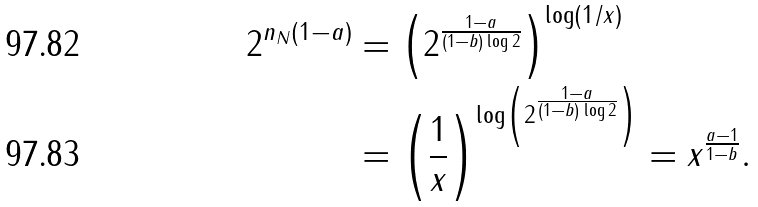<formula> <loc_0><loc_0><loc_500><loc_500>2 ^ { n _ { N } ( 1 - a ) } & = \left ( 2 ^ { \frac { 1 - a } { ( 1 - b ) \log 2 } } \right ) ^ { \log ( 1 / x ) } \\ & = \left ( \frac { 1 } { x } \right ) ^ { \log \left ( 2 ^ { \frac { 1 - a } { ( 1 - b ) \log 2 } } \right ) } = x ^ { \frac { a - 1 } { 1 - b } } .</formula> 